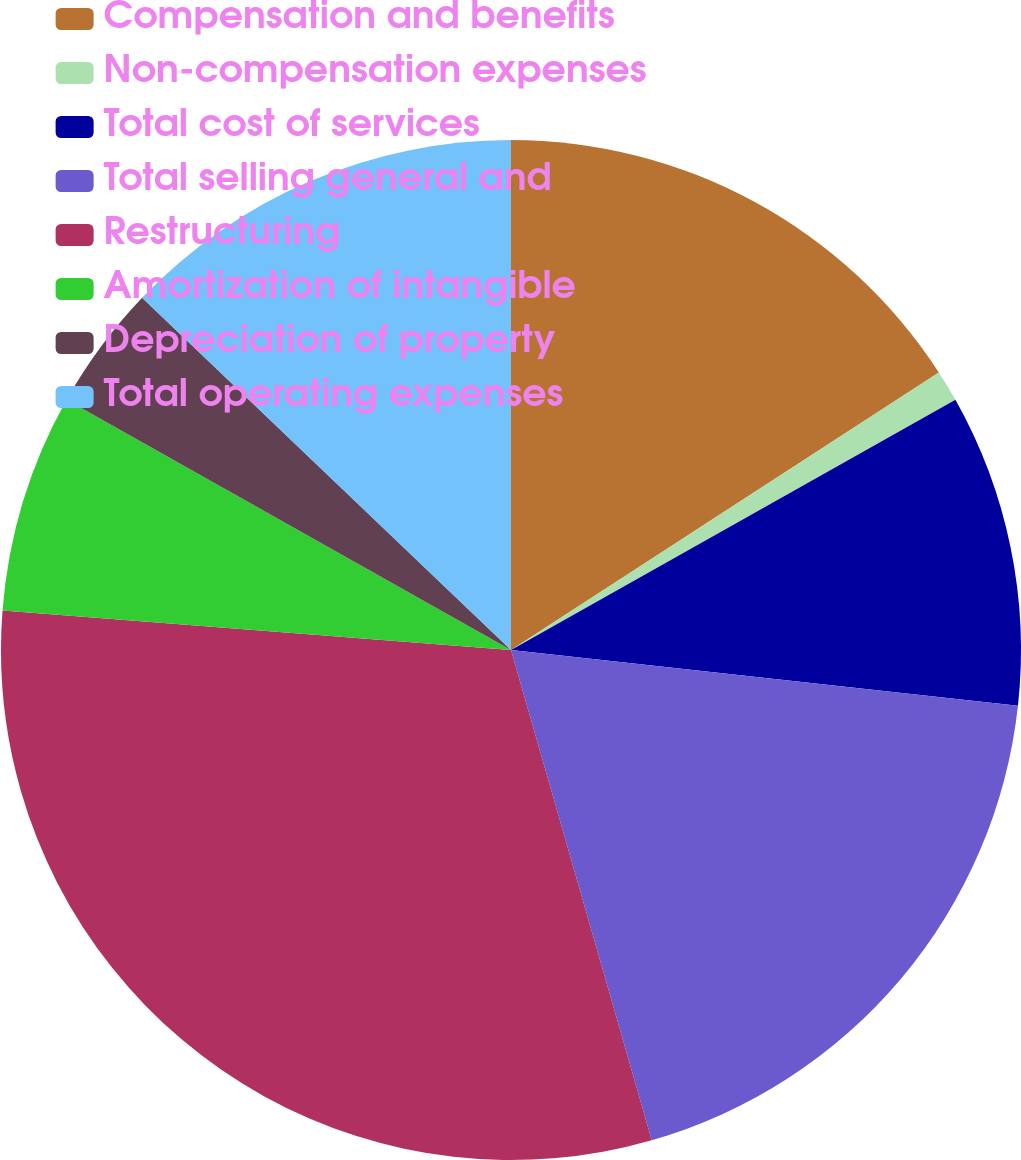<chart> <loc_0><loc_0><loc_500><loc_500><pie_chart><fcel>Compensation and benefits<fcel>Non-compensation expenses<fcel>Total cost of services<fcel>Total selling general and<fcel>Restructuring<fcel>Amortization of intangible<fcel>Depreciation of property<fcel>Total operating expenses<nl><fcel>15.84%<fcel>1.0%<fcel>9.9%<fcel>18.81%<fcel>30.68%<fcel>6.93%<fcel>3.97%<fcel>12.87%<nl></chart> 